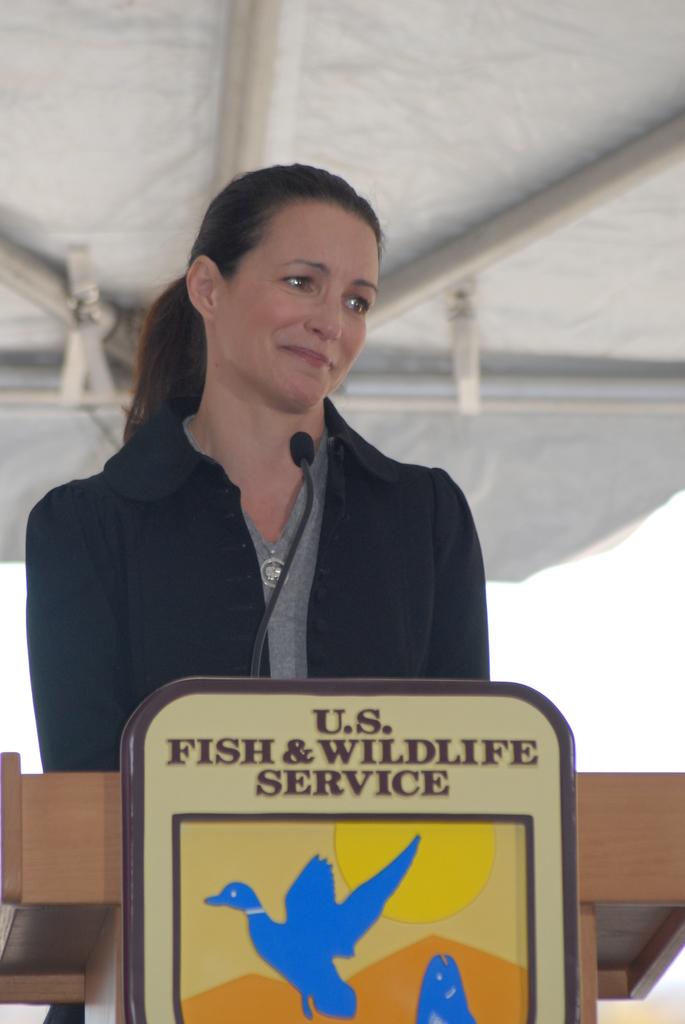She represents what country's fish and wildlife service?
Your answer should be compact. U.s. What kind of service?
Offer a very short reply. U.s. fish & wildlife. 